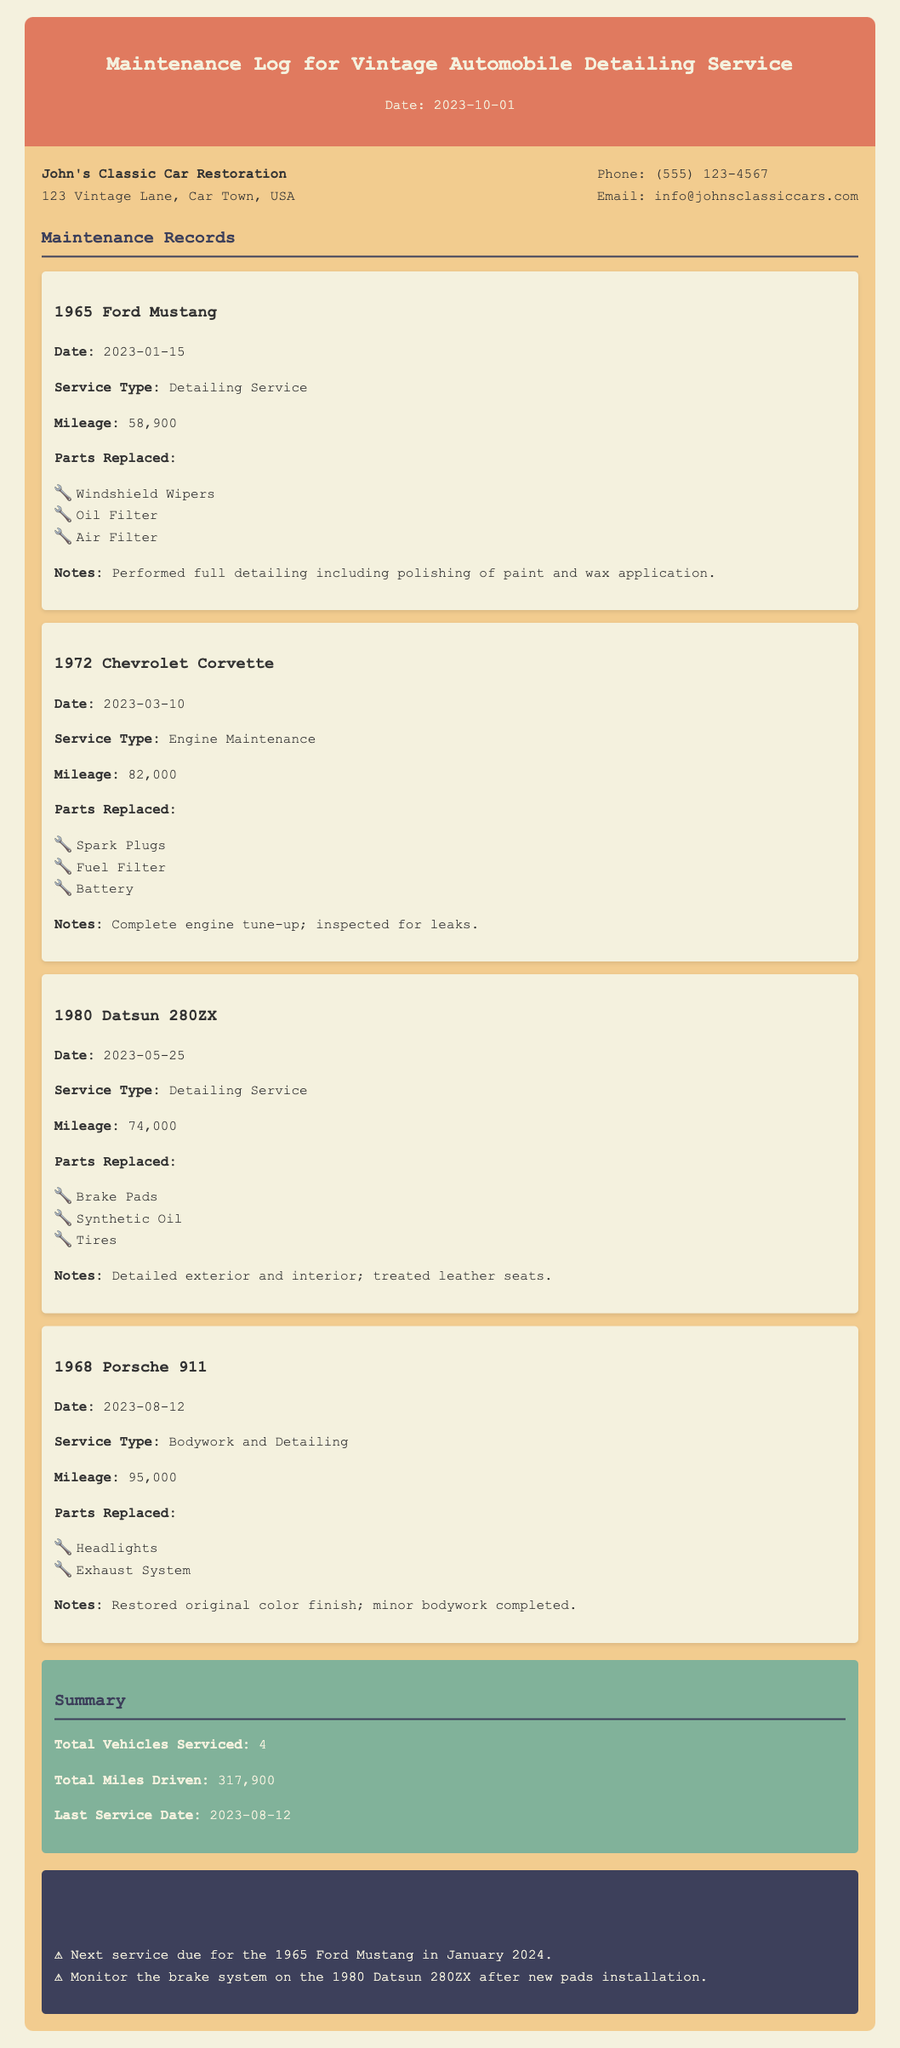What is the date of the last service? The last service date recorded in the document is found in the summary section.
Answer: 2023-08-12 Which vehicle had detailing service on 2023-01-15? This information can be found in the maintenance records where the date and service type are specified together.
Answer: 1965 Ford Mustang How many vehicles were serviced in total? The total number of vehicles serviced is summarized in the last part of the memo.
Answer: 4 What parts were replaced in the 1972 Chevrolet Corvette maintenance? The parts replaced are listed in the maintenance record for the 1972 Chevrolet Corvette.
Answer: Spark Plugs, Fuel Filter, Battery What was the mileage of the 1980 Datsun 280ZX during its last service? This information is provided in the maintenance record stating the mileage at the time of service.
Answer: 74,000 What type of service did the 1968 Porsche 911 receive? The type of service for each vehicle is mentioned in the maintenance records specific to that vehicle.
Answer: Bodywork and Detailing What reminder is provided for the 1965 Ford Mustang? The reminders section contains specific notes regarding upcoming services for the vehicles.
Answer: Next service due for the 1965 Ford Mustang in January 2024 What was done during the detailing service for the 1965 Ford Mustang? Notes in the maintenance record provide specific details about the services rendered.
Answer: Performed full detailing including polishing of paint and wax application 